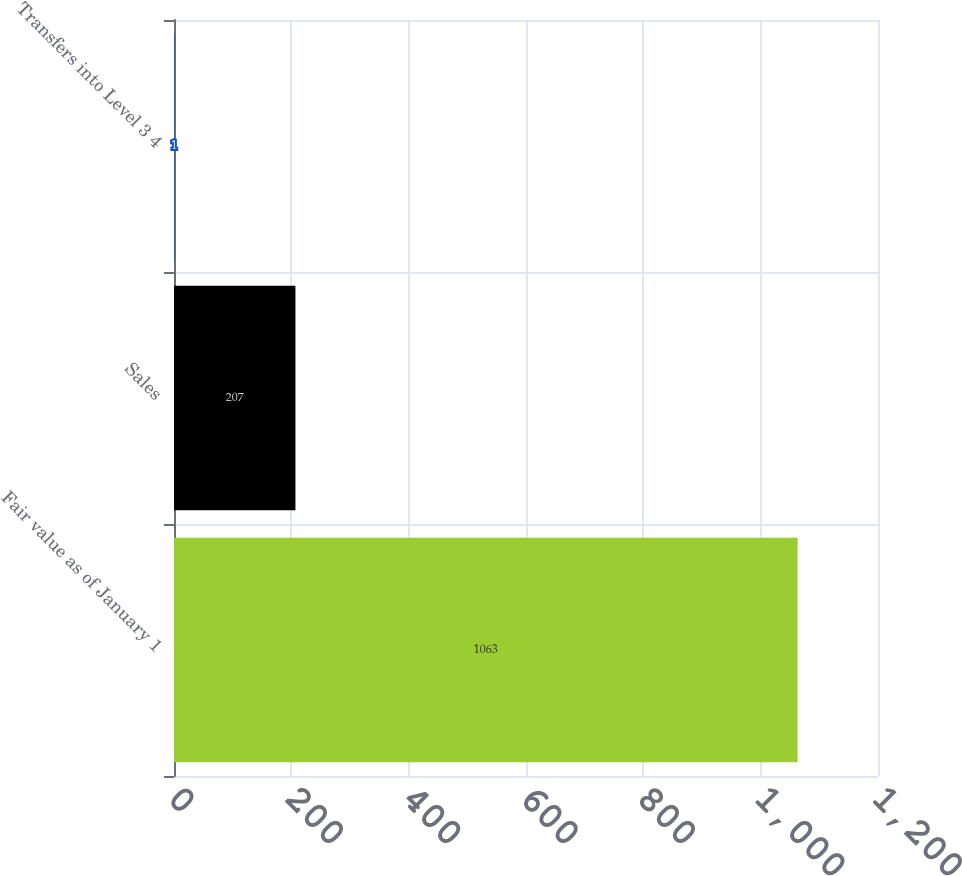<chart> <loc_0><loc_0><loc_500><loc_500><bar_chart><fcel>Fair value as of January 1<fcel>Sales<fcel>Transfers into Level 3 4<nl><fcel>1063<fcel>207<fcel>1<nl></chart> 